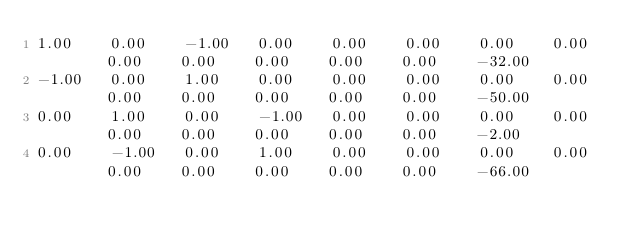<code> <loc_0><loc_0><loc_500><loc_500><_Matlab_>1.00	0.00	-1.00	0.00	0.00	0.00	0.00	0.00	0.00	0.00	0.00	0.00	0.00	-32.00
-1.00	0.00	1.00	0.00	0.00	0.00	0.00	0.00	0.00	0.00	0.00	0.00	0.00	-50.00
0.00	1.00	0.00	-1.00	0.00	0.00	0.00	0.00	0.00	0.00	0.00	0.00	0.00	-2.00
0.00	-1.00	0.00	1.00	0.00	0.00	0.00	0.00	0.00	0.00	0.00	0.00	0.00	-66.00
</code> 